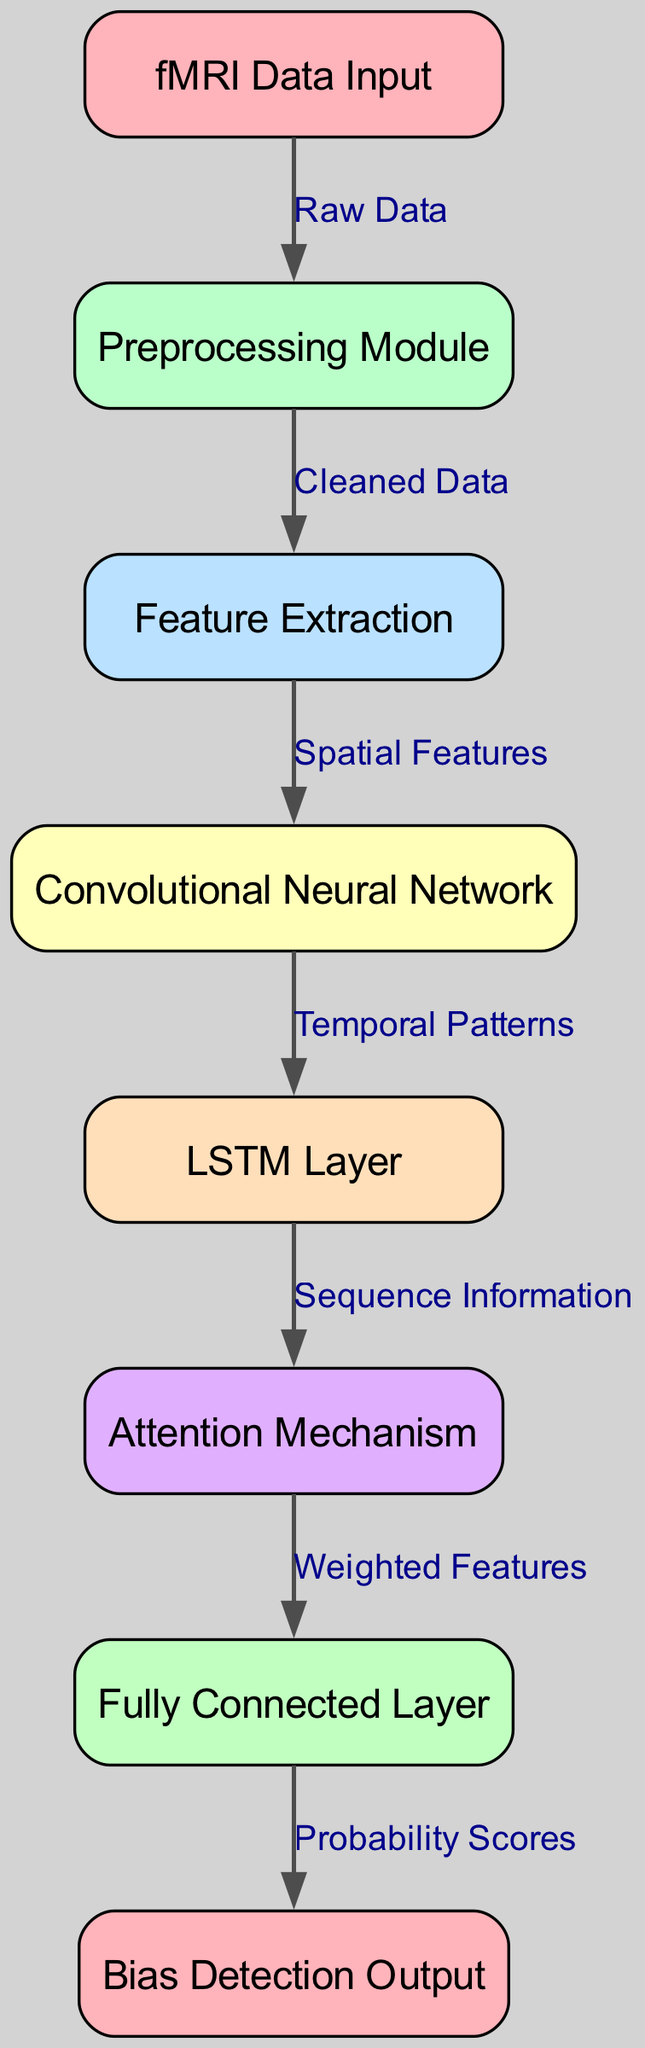What is the first node in the diagram? The diagram starts with the 'fMRI Data Input' node, which is indicated as the first component.
Answer: fMRI Data Input How many edges are in the diagram? By counting the connections between the nodes, there are a total of 6 edges in the diagram.
Answer: 6 What type of layer follows the 'Convolutional Neural Network' node? After the 'Convolutional Neural Network' node, the 'LSTM Layer' node is the next component in the sequence, indicating that this layer processes temporal information.
Answer: LSTM Layer What does the 'Attention Mechanism' node receive as input? The 'Attention Mechanism' node receives input from the 'LSTM Layer', which supplies it with sequence information for further processing.
Answer: Sequence Information Which node is responsible for outputting probability scores? The last node in the sequence is the 'Bias Detection Output', which is responsible for providing the final probability scores related to implicit bias detection.
Answer: Bias Detection Output Which node processes cleaned data? The 'Feature Extraction' node is where the cleaned data from the preprocessing module is processed to extract relevant features for further analysis.
Answer: Feature Extraction What is the relationship between 'Feature Extraction' and 'Convolutional Neural Network'? The 'Feature Extraction' node outputs spatial features that are then utilized by the 'Convolutional Neural Network' node for further processing, thus establishing a directional relationship.
Answer: Spatial Features What module cleans the raw data? The module responsible for cleaning the raw data is the 'Preprocessing Module', which ensures that the inputs are suitable for subsequent analysis.
Answer: Preprocessing Module Which component extracts features from the fMRI data after preprocessing? The component that extracts features from the fMRI data after preprocessing is the 'Feature Extraction' node, which prepares relevant features for subsequent layers.
Answer: Feature Extraction 